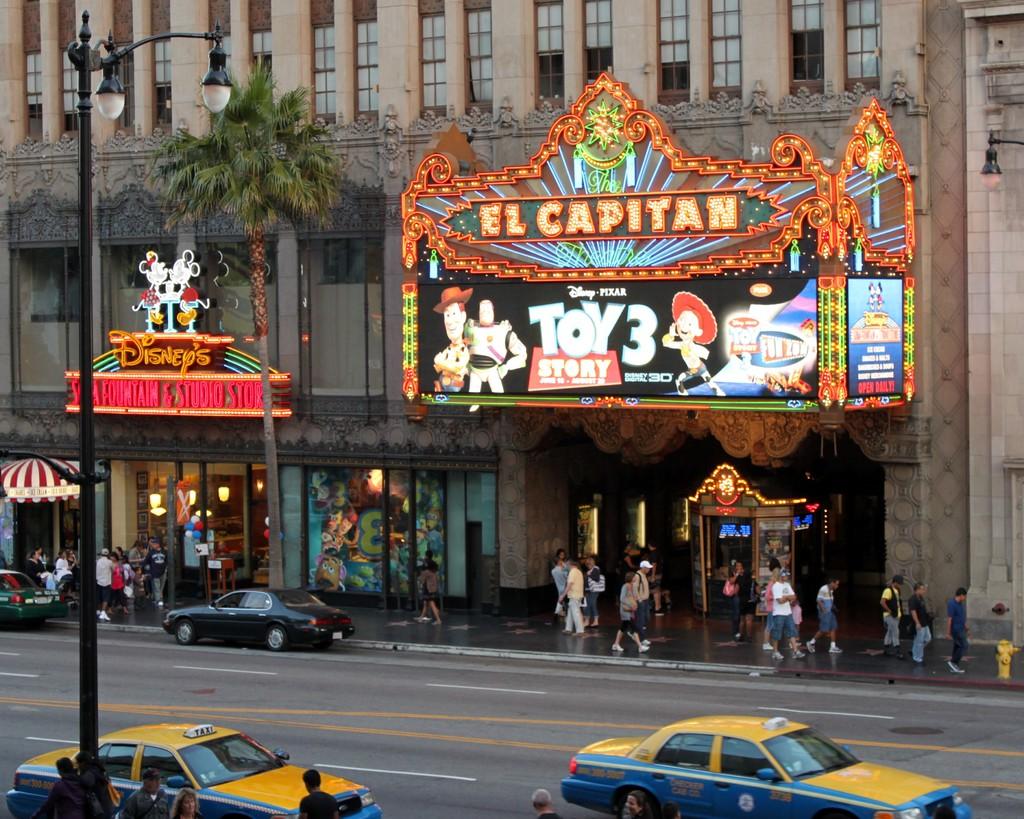What movie is playing?
Offer a terse response. Toy story 3. 